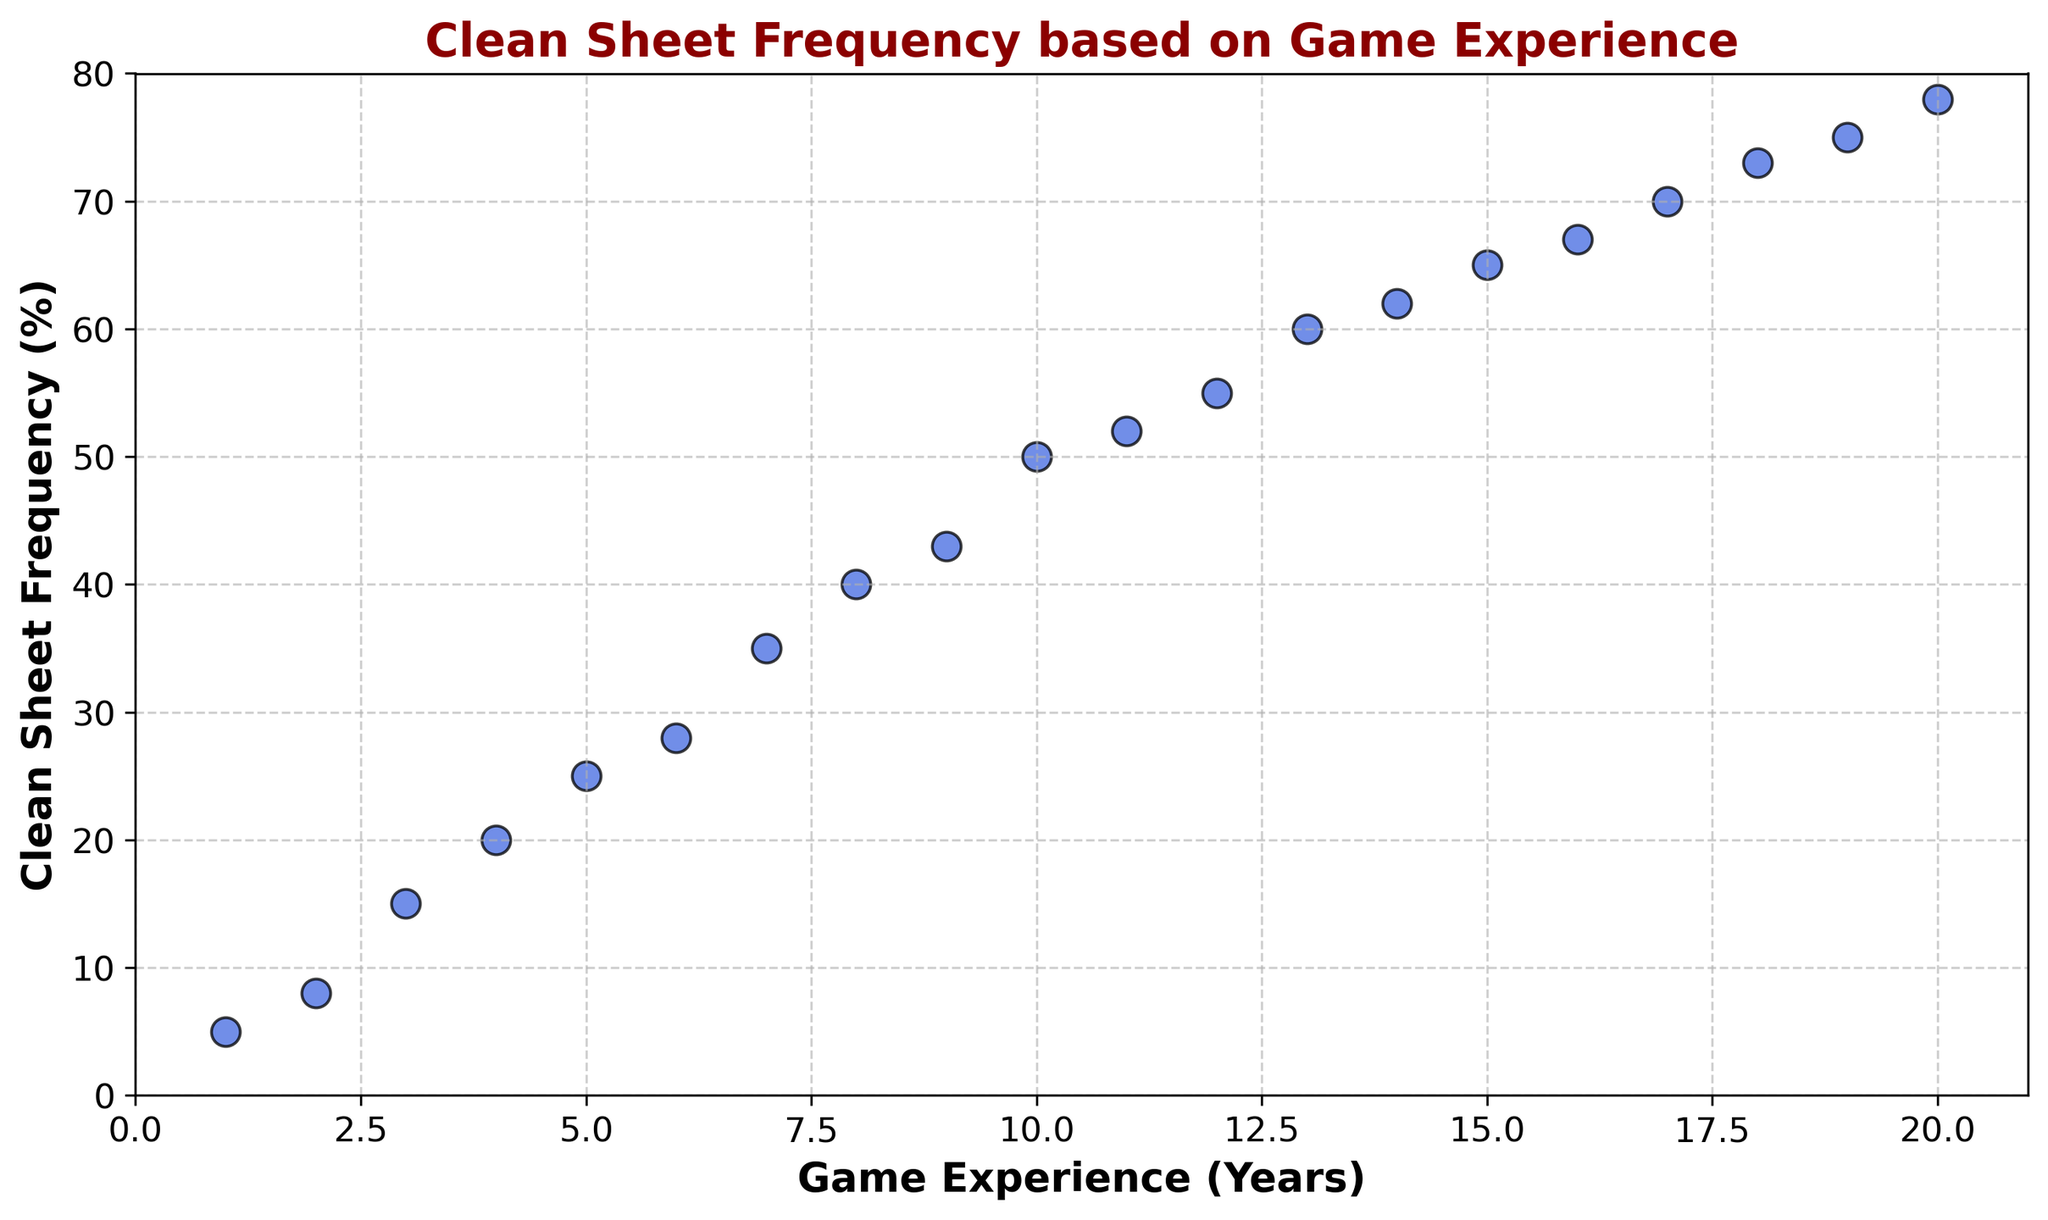What is the clean sheet frequency for a goalkeeper with 10 years of game experience? Locate the data point where 'Game Experience (Years)' is 10 and check the corresponding 'Clean Sheet Frequency (Percentage)'. The point (10, 50) indicates that the frequency of clean sheets for a goalkeeper with 10 years of experience is 50%.
Answer: 50% On average, how much does the clean sheet frequency increase per year of game experience between 1 and 5 years? Calculate the clean sheet frequency for 1 and 5 years (5% and 25%, respectively). The increase over these 4 years is 25% - 5% = 20%. Divide this by 4 years for the average increase per year: 20% / 4 = 5% per year.
Answer: 5% per year Which year marks the first time a goalkeeper, on average, achieves a clean sheet frequency of at least 50%? Identify the data point where 'Clean Sheet Frequency (Percentage)' first reaches or exceeds 50%. The point (10, 50) indicates that a goalkeeper with 10 years of game experience achieves a 50% clean sheet frequency.
Answer: 10 years Is there a clear trend between game experience and clean sheet frequency? Observe the scatter plot where the 'Game Experience (Years)' is on the x-axis and 'Clean Sheet Frequency (Percentage)' is on the y-axis. Note the positive slope of the plotted points, indicating a clear trend: as game experience increases, clean sheet frequency also increases.
Answer: Yes Between which two consecutive years is the largest increase in clean sheet frequency observed? Examine the differences in clean sheet frequencies between consecutive years. The largest increase is between 2 years (8%) and 3 years (15%), where the increase is 15% - 8% = 7%.
Answer: Between 2 and 3 years What is the clean sheet frequency for experienced goalkeepers with 15 years and 20 years of experience? Locate the data points for 15 years and 20 years of experience. The points (15, 65) and (20, 78) indicate clean sheet frequencies of 65% and 78%, respectively.
Answer: 65% and 78% What is the difference in clean sheet frequency between goalkeepers with 8 years and 18 years of experience? Identify the clean sheet frequencies for 8 years (40%) and 18 years (73%). Subtract the smaller value from the larger: 73% - 40% = 33%.
Answer: 33% By what percentage does the clean sheet frequency increase from 5 years to 10 years of experience, and how significant is this difference visually? Calculate the clean sheet frequencies for 5 years (25%) and 10 years (50%). The increase is 50% - 25% = 25%. Visually, this difference is significant as the plot shows a steep upward trend between these two points.
Answer: 25% increase, significant visually At 14 years of experience, how much more frequent are clean sheets compared to 4 years of experience? For 14 years, the clean sheet frequency is 62%, and for 4 years, it is 20%. Calculate the difference: 62% - 20% = 42%.
Answer: 42% Which interval shows a decreasing rate of increase in clean sheet frequency compared to earlier years, and why might this occur? Observe the slope of the graph across different intervals. Notice that the increase in clean sheet frequency starts to slow after around 15 years of experience, where the increase becomes less steep. This might occur due to the law of diminishing returns or reaching a performance plateau.
Answer: After 15 years, law of diminishing returns 